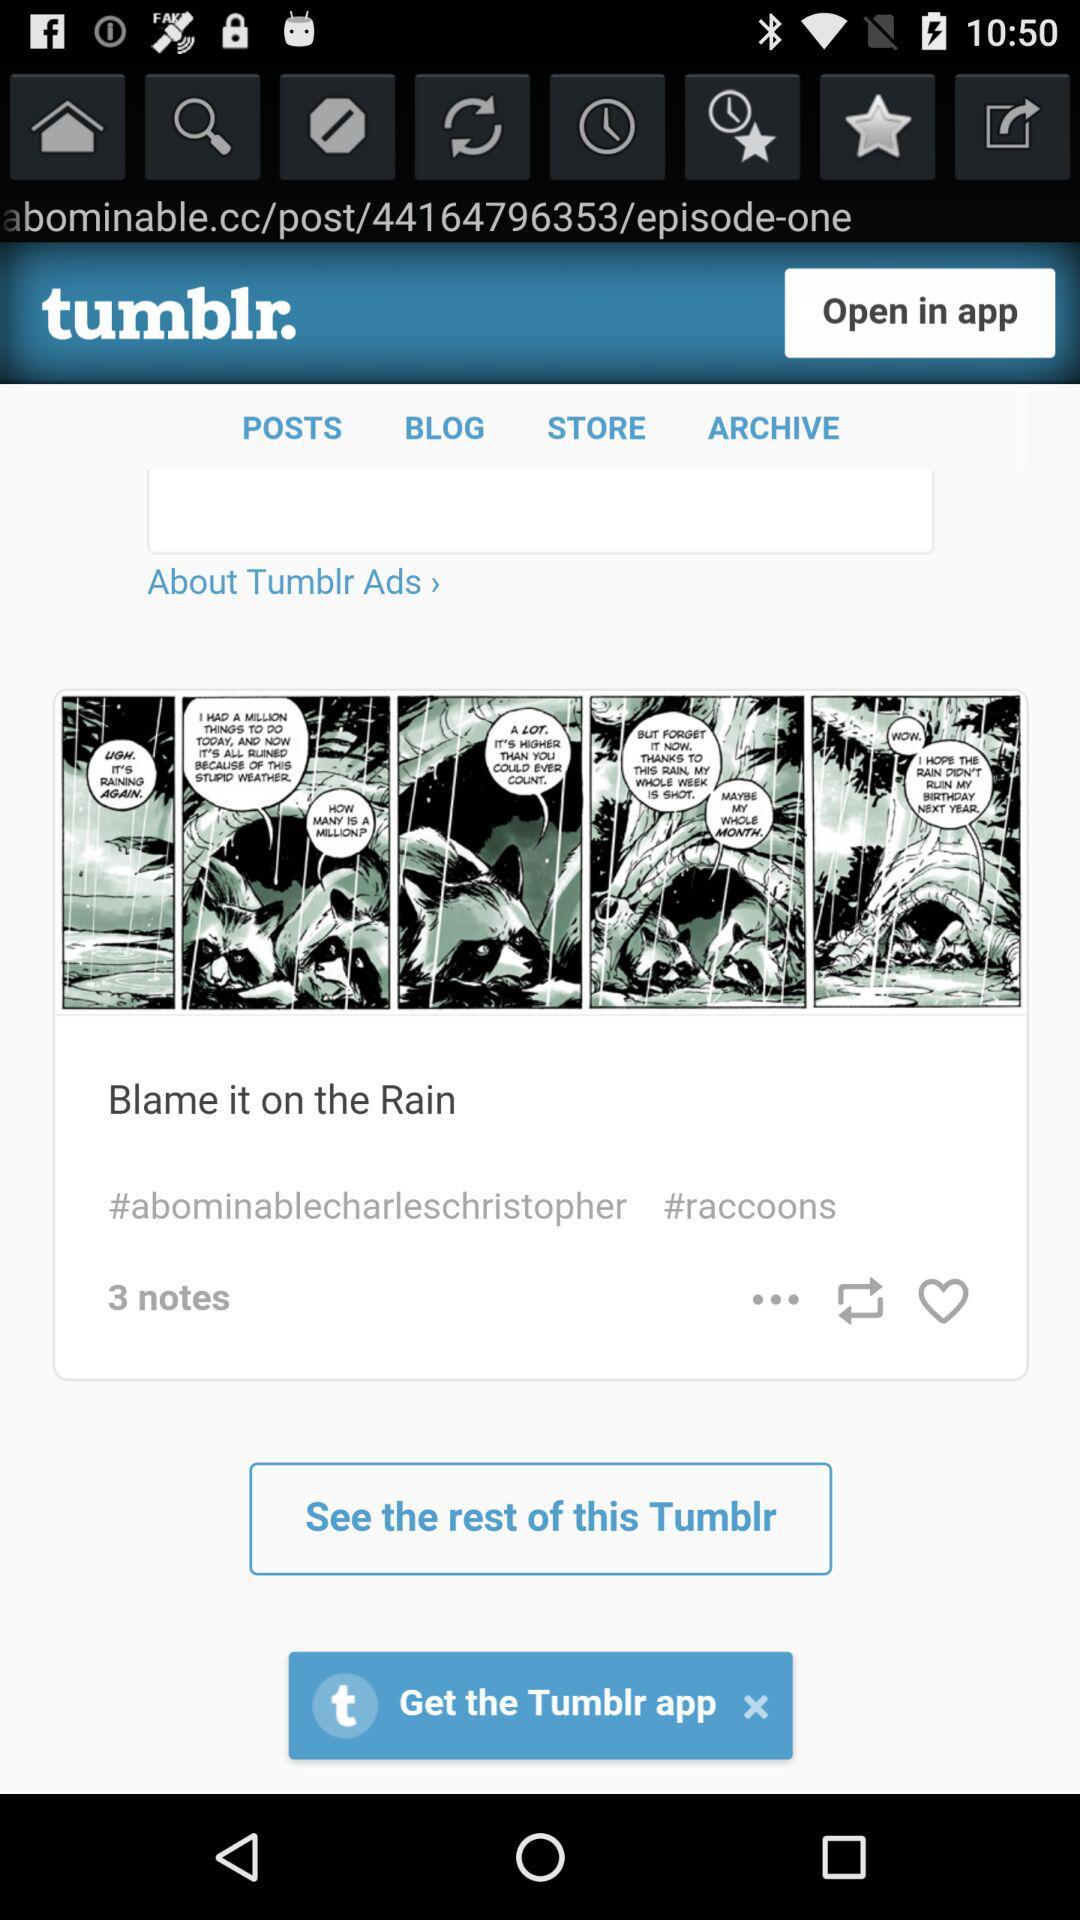How many notes are there on this post?
Answer the question using a single word or phrase. 3 